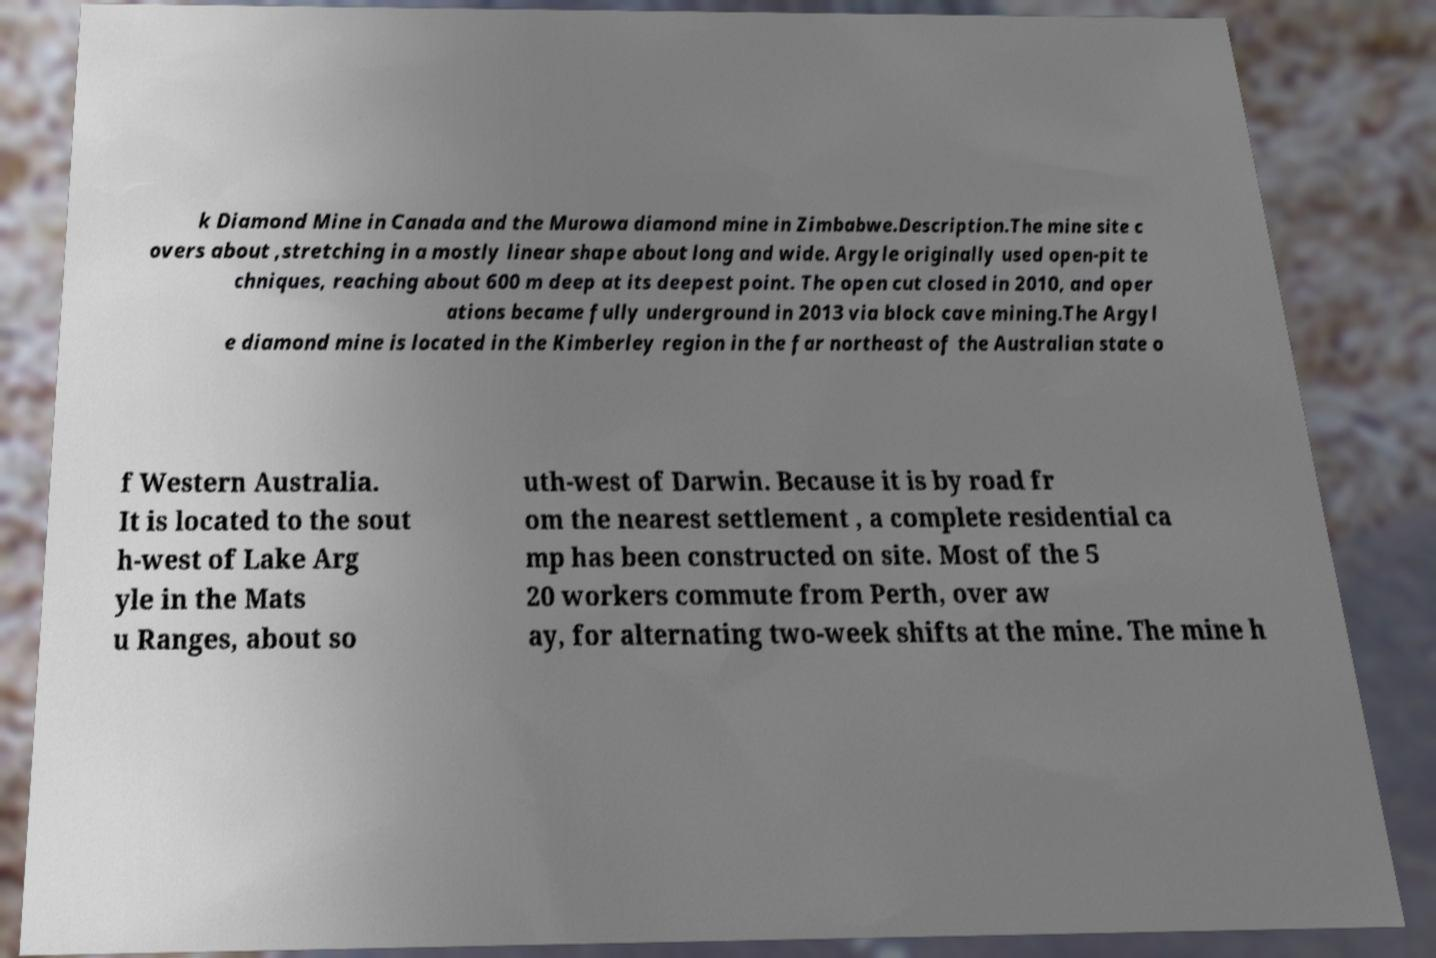Could you extract and type out the text from this image? k Diamond Mine in Canada and the Murowa diamond mine in Zimbabwe.Description.The mine site c overs about ,stretching in a mostly linear shape about long and wide. Argyle originally used open-pit te chniques, reaching about 600 m deep at its deepest point. The open cut closed in 2010, and oper ations became fully underground in 2013 via block cave mining.The Argyl e diamond mine is located in the Kimberley region in the far northeast of the Australian state o f Western Australia. It is located to the sout h-west of Lake Arg yle in the Mats u Ranges, about so uth-west of Darwin. Because it is by road fr om the nearest settlement , a complete residential ca mp has been constructed on site. Most of the 5 20 workers commute from Perth, over aw ay, for alternating two-week shifts at the mine. The mine h 